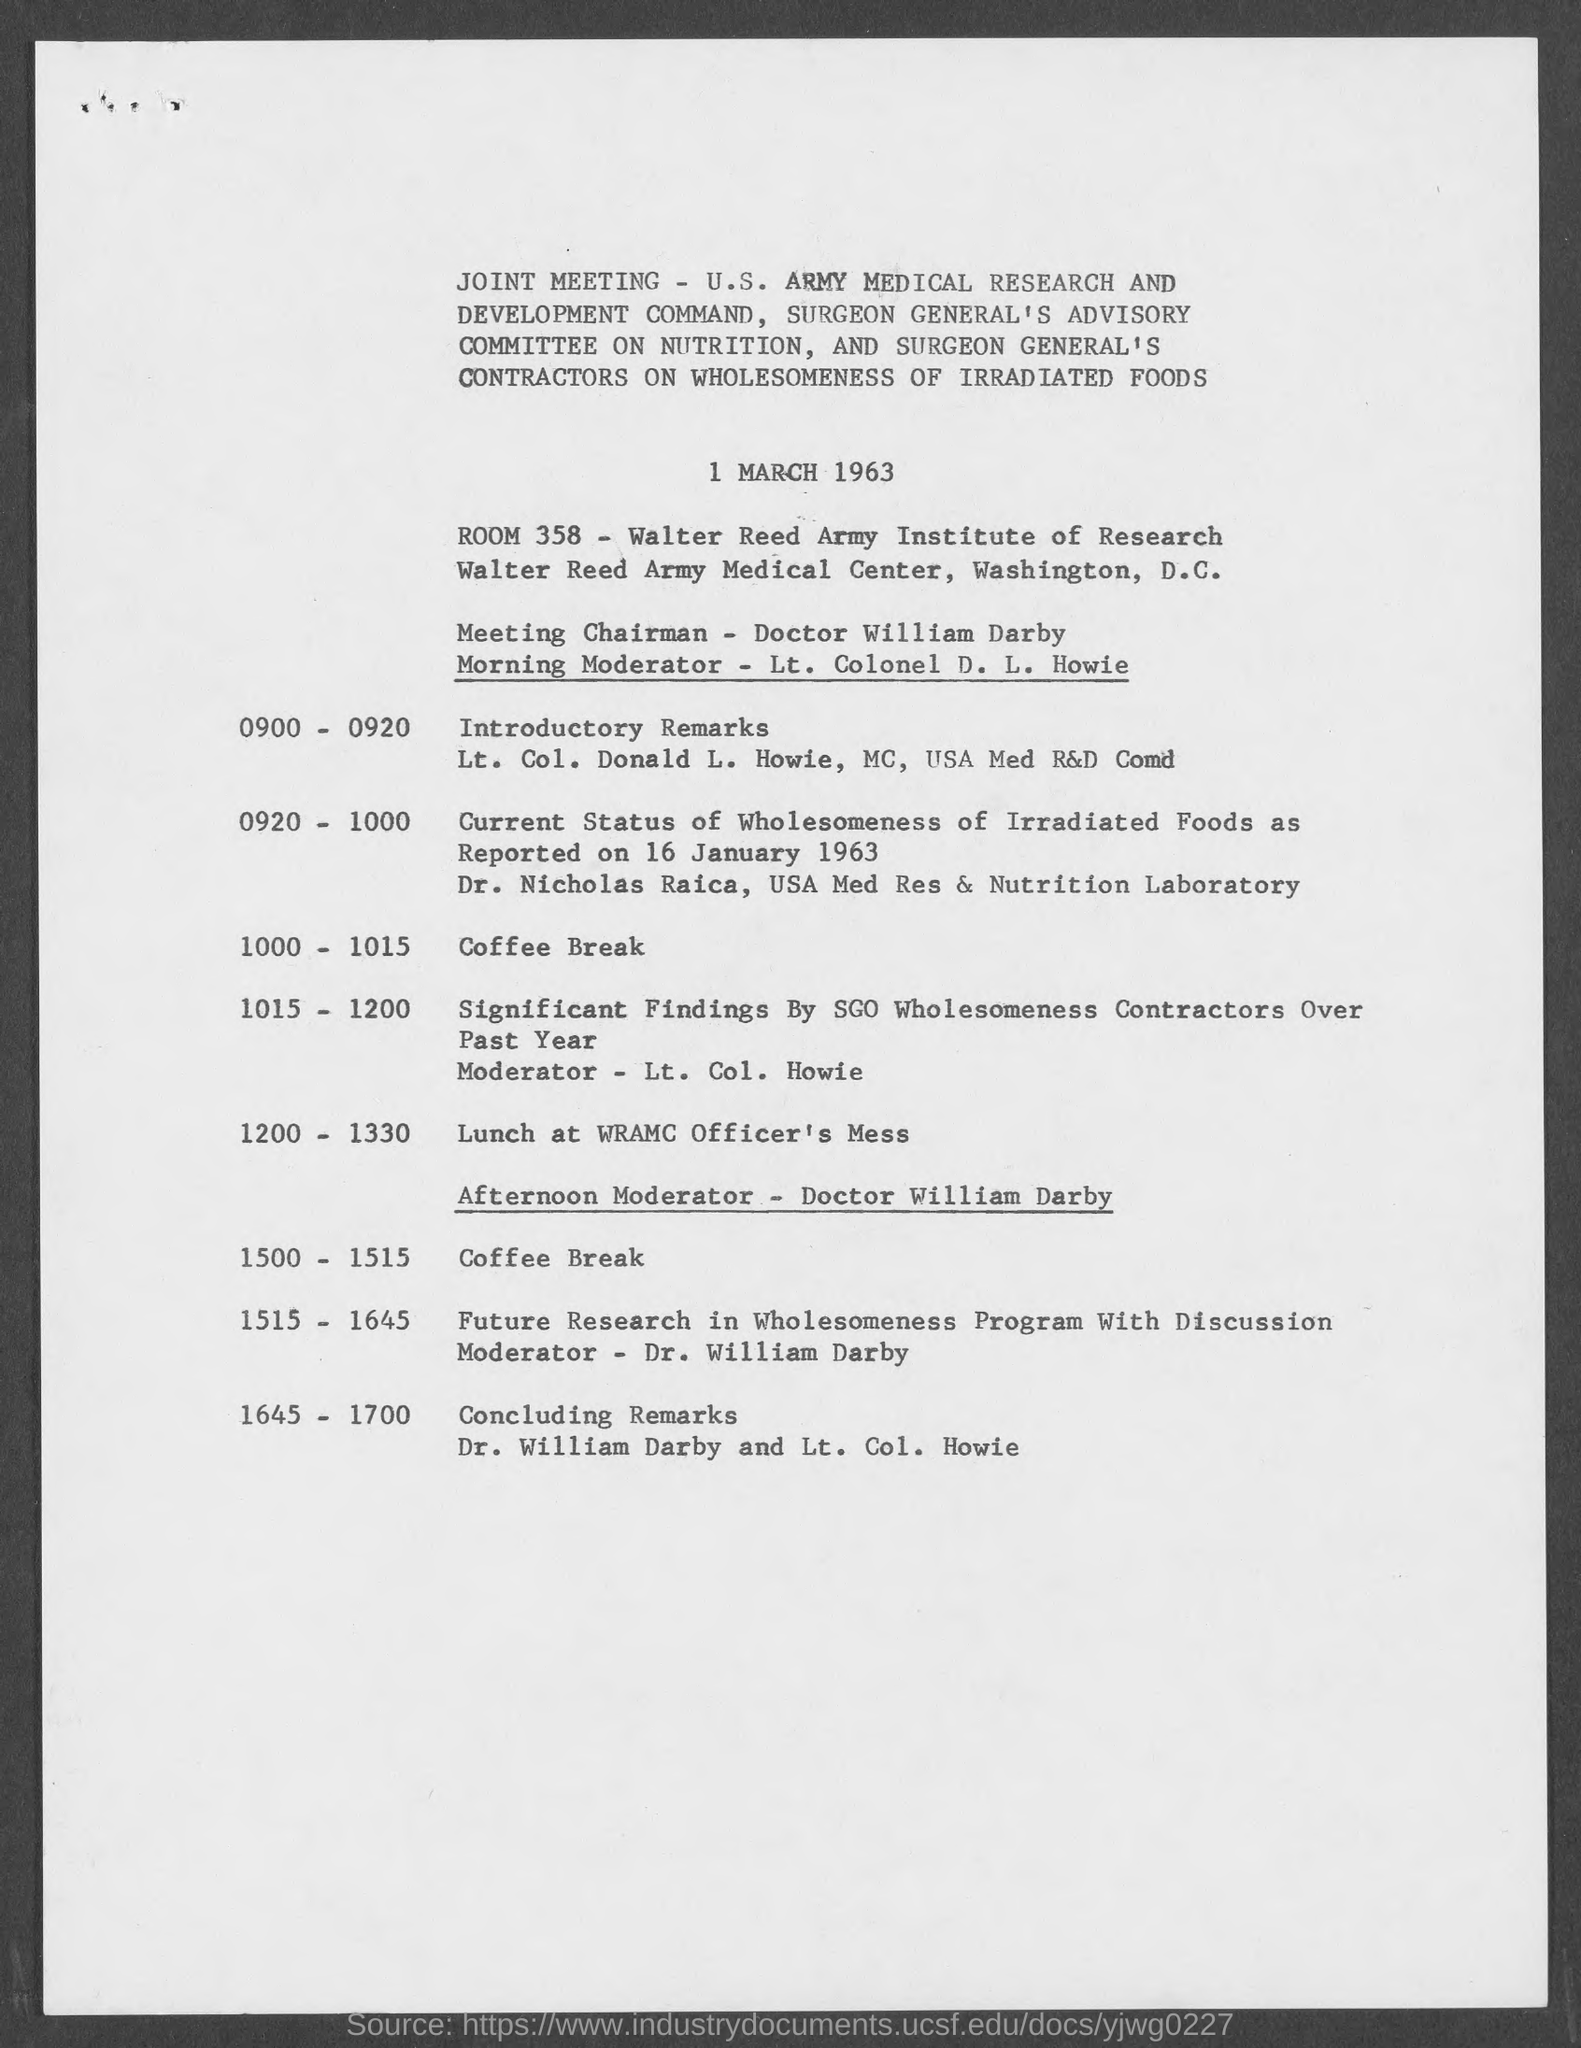Who is the Meeting Chairman as per the document?
Your answer should be very brief. Doctor William Darby. Who is the Moderator for the Morning Sessions?
Offer a very short reply. Lt. Colonel D. L. Howie. What date is the joint meeting held as per the document?
Make the answer very short. 1 MARCH 1963. Who is the Moderator for the afternoon Session?
Ensure brevity in your answer.  Doctor William Darby. Who is giving the concluding remarks for the meeting?
Provide a succinct answer. Dr. William Darby and Lt. Col. Howie. 